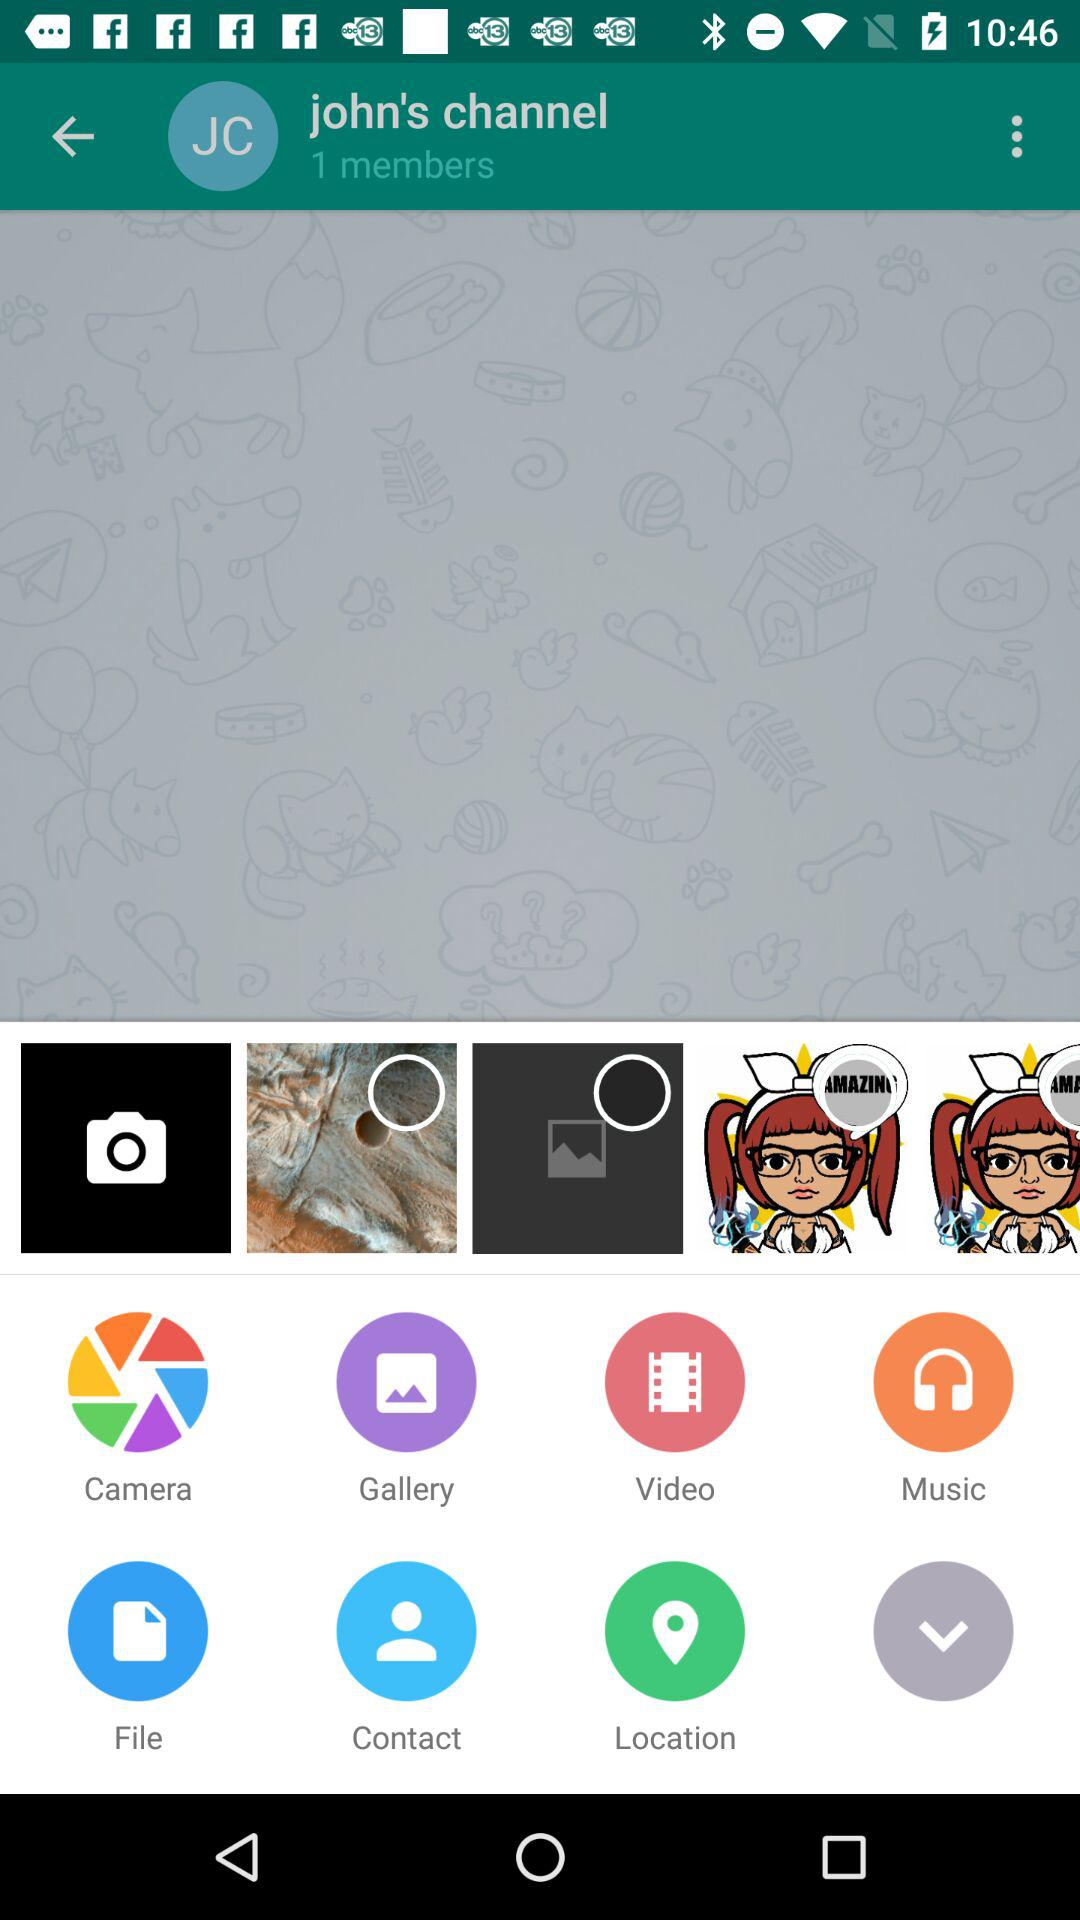What is the name of the channel? The name of the channel is "john's channel". 